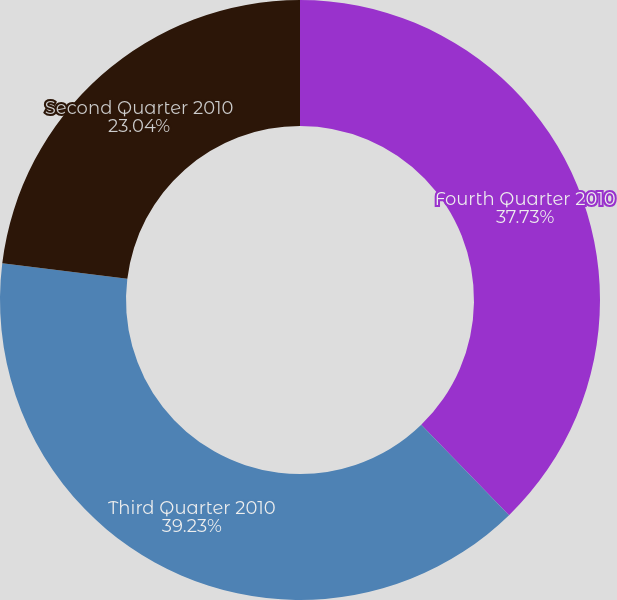<chart> <loc_0><loc_0><loc_500><loc_500><pie_chart><fcel>Fourth Quarter 2010<fcel>Third Quarter 2010<fcel>Second Quarter 2010<nl><fcel>37.73%<fcel>39.23%<fcel>23.04%<nl></chart> 